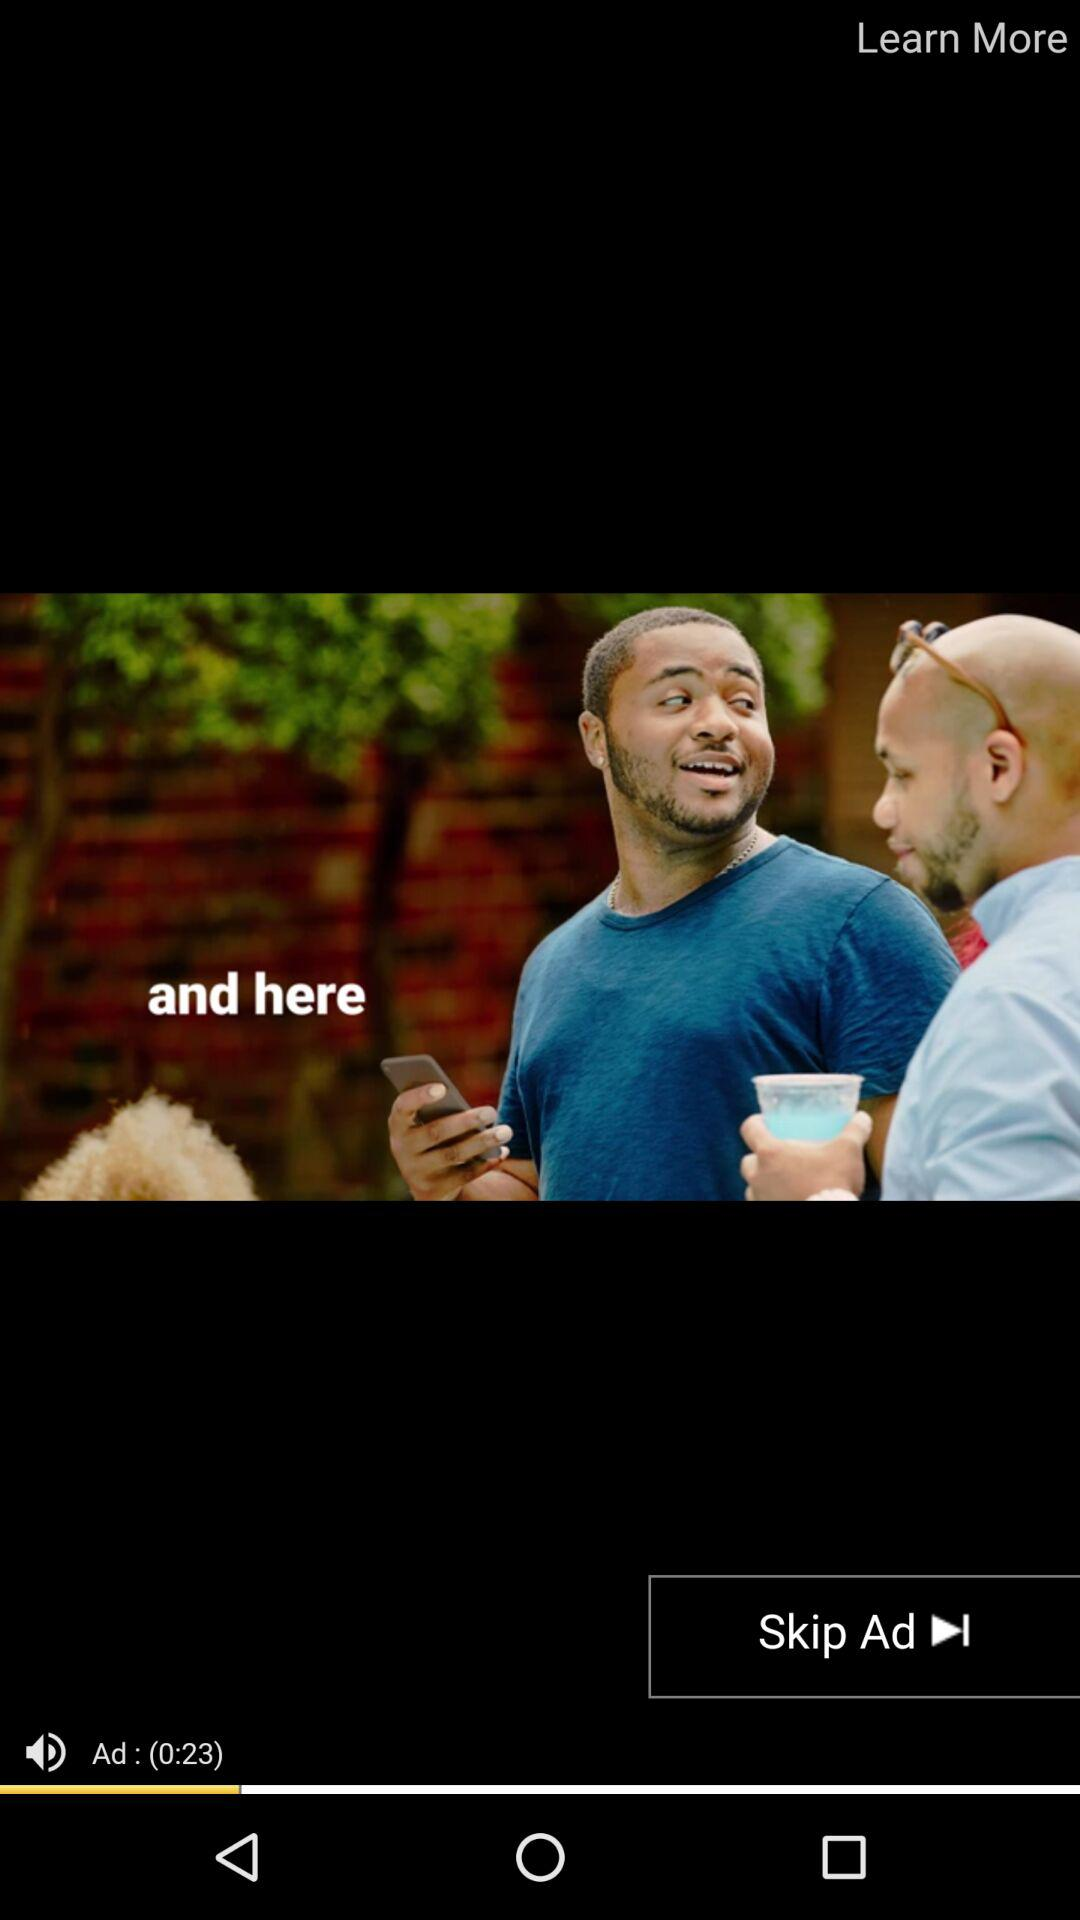How many seconds long is the ad?
Answer the question using a single word or phrase. 23 